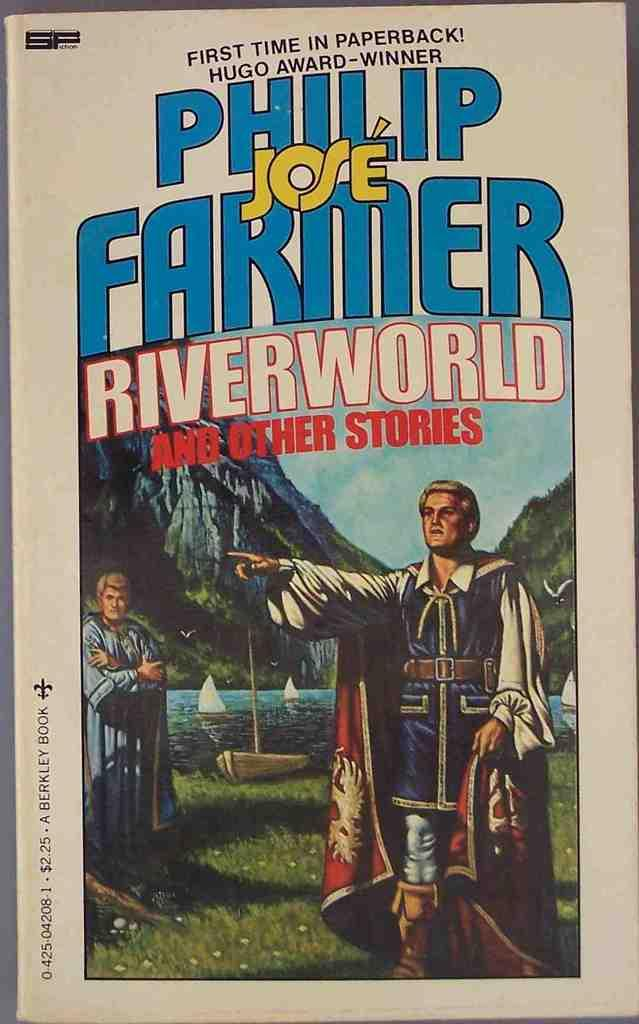<image>
Describe the image concisely. Philip Jose Farmer Riverworld and other stories paperback. 